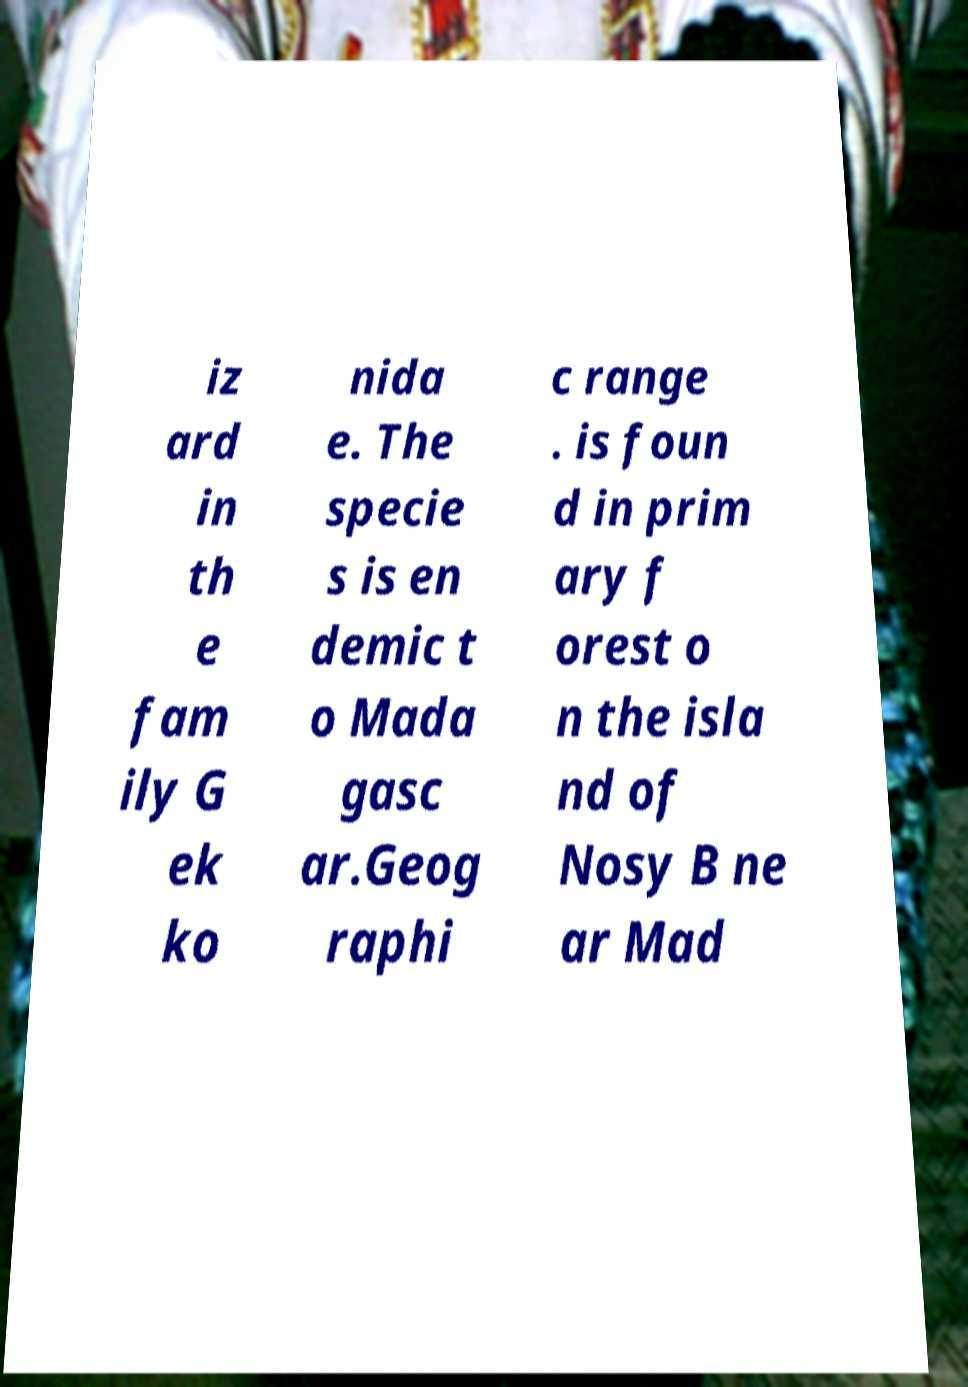There's text embedded in this image that I need extracted. Can you transcribe it verbatim? iz ard in th e fam ily G ek ko nida e. The specie s is en demic t o Mada gasc ar.Geog raphi c range . is foun d in prim ary f orest o n the isla nd of Nosy B ne ar Mad 